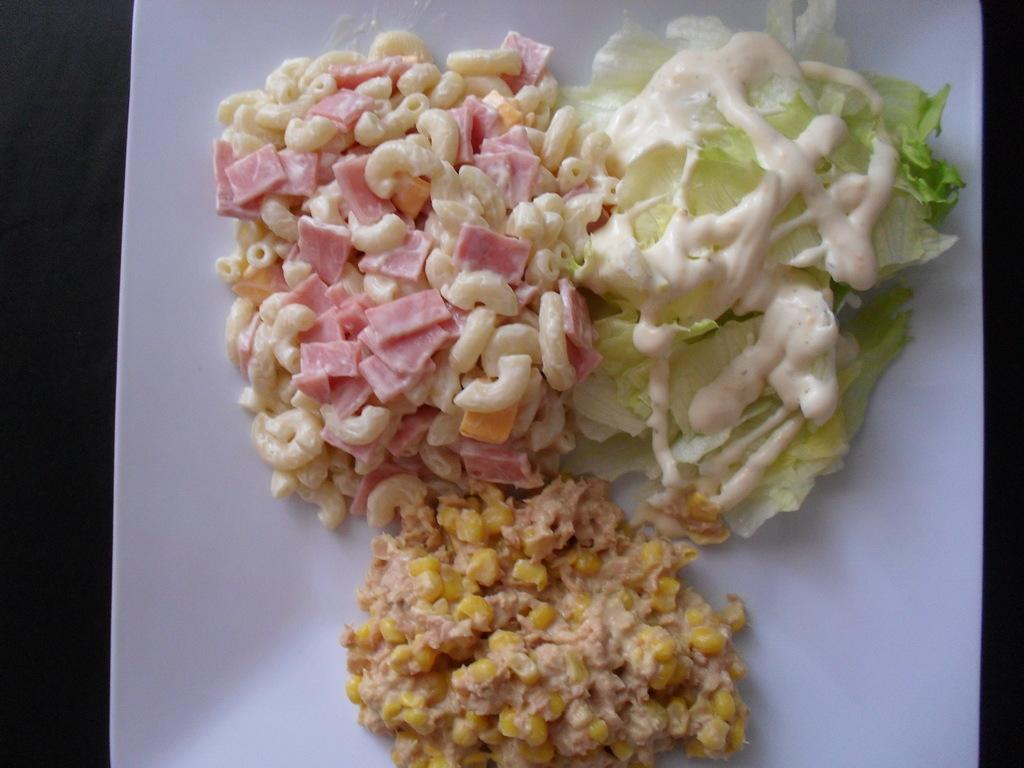What is on the white plate in the image? There is food on a white plate in the image. What colors are present on the sides of the image? The right side and left side of the image have black color. Can you see a cork floating in the food on the plate? There is no cork present in the image, and it is not mentioned that there is any liquid in the food. 